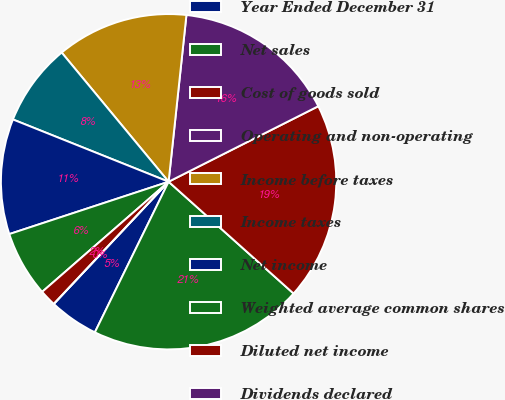Convert chart to OTSL. <chart><loc_0><loc_0><loc_500><loc_500><pie_chart><fcel>Year Ended December 31<fcel>Net sales<fcel>Cost of goods sold<fcel>Operating and non-operating<fcel>Income before taxes<fcel>Income taxes<fcel>Net income<fcel>Weighted average common shares<fcel>Diluted net income<fcel>Dividends declared<nl><fcel>4.76%<fcel>20.63%<fcel>19.05%<fcel>15.87%<fcel>12.7%<fcel>7.94%<fcel>11.11%<fcel>6.35%<fcel>1.59%<fcel>0.0%<nl></chart> 